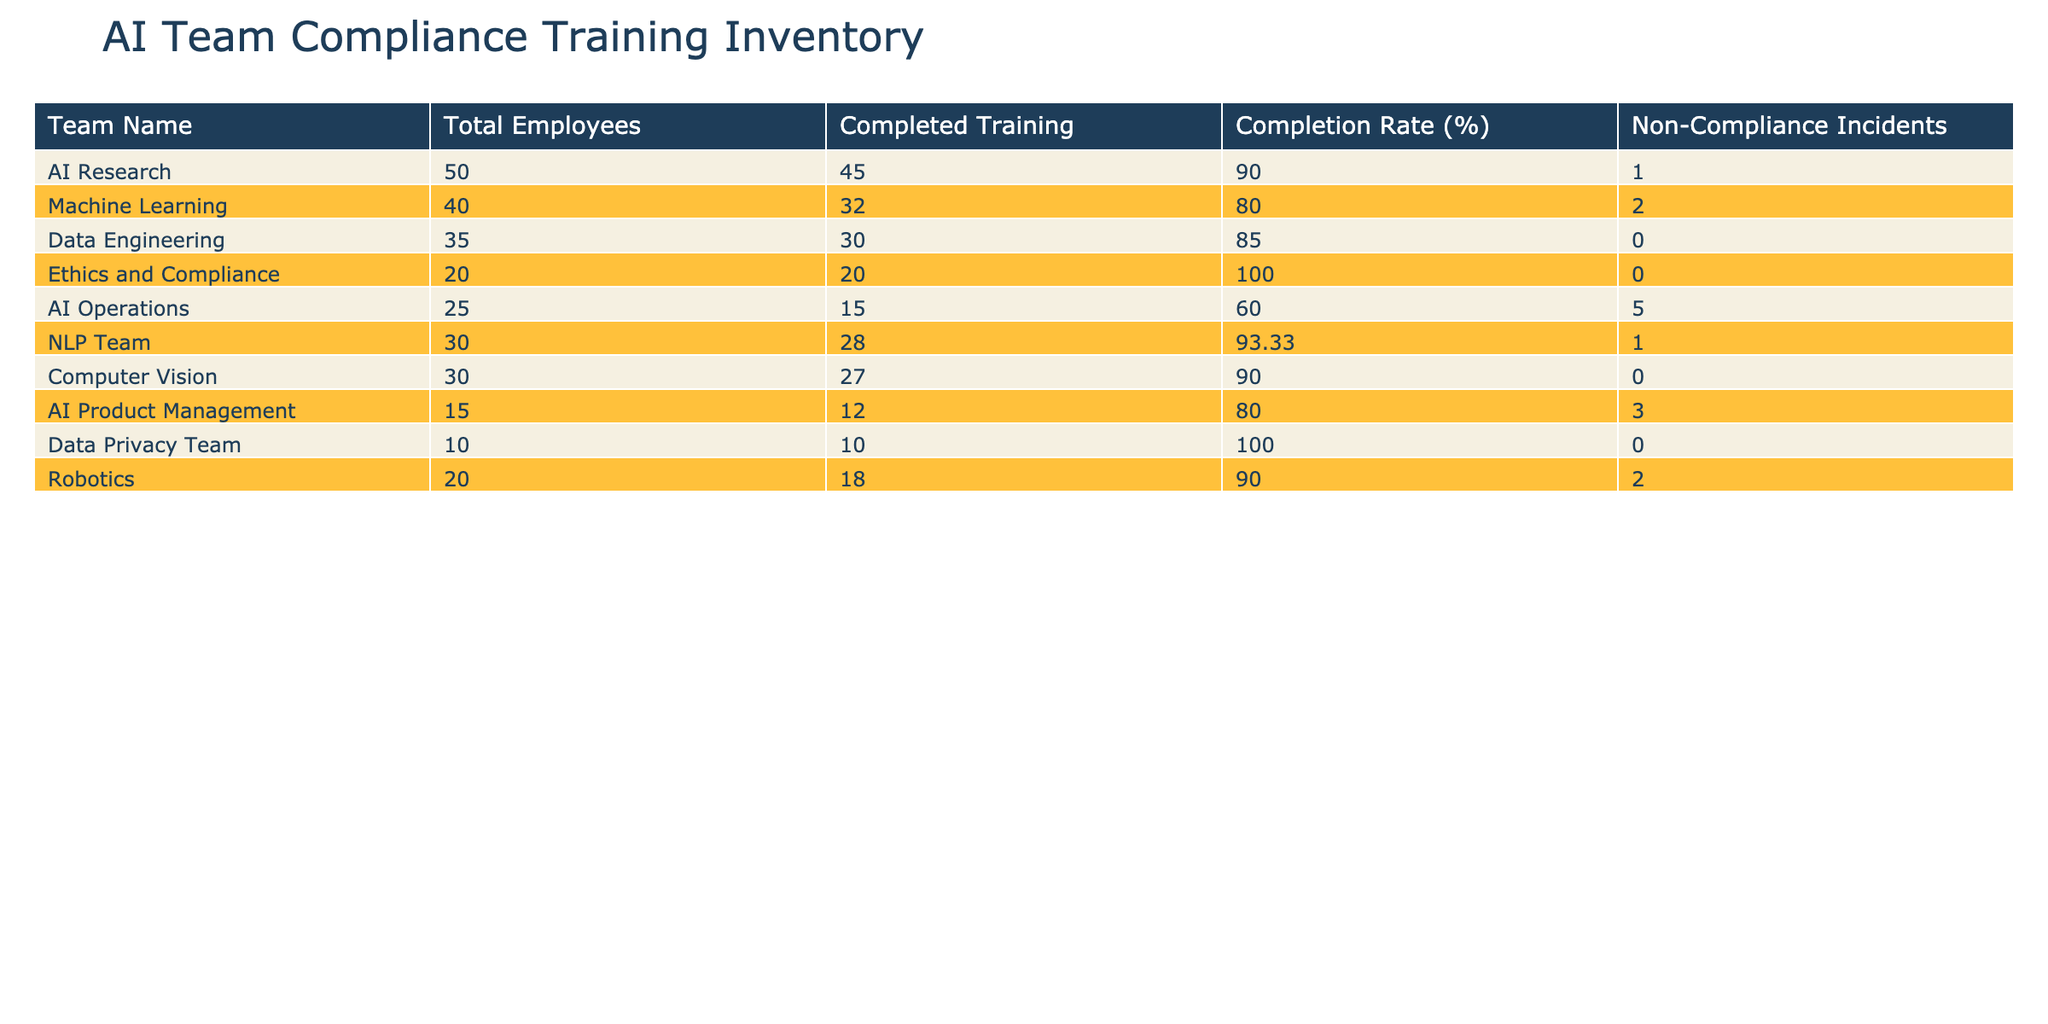What is the completion rate for the Ethics and Compliance team? The completion rate for the Ethics and Compliance team is directly listed in the table under the "Completion Rate (%)" column. The value for this team is 100%.
Answer: 100% Which team has the lowest completion rate? To find the team with the lowest completion rate, we need to look through the "Completion Rate (%)" column and identify the minimum value, which is 60% for the AI Operations team.
Answer: AI Operations How many non-compliance incidents were reported by the Data Engineering team? The number of non-compliance incidents for the Data Engineering team can be found in the "Non-Compliance Incidents" column. For this team, the number is 0.
Answer: 0 What is the average completion rate for all teams combined? To calculate the average, we first add all the completion rates: 90 + 80 + 85 + 100 + 60 + 93.33 + 90 + 80 + 100 + 90 = 968.33. Next, we divide by the number of teams, which is 10, resulting in an average of 96.83%.
Answer: 96.83% Is there any team that has a 100% training completion rate? We can review the completion rates listed in the table. The Data Privacy Team and the Ethics and Compliance Team both have a completion rate of 100%. Thus, the answer is yes, there are teams with 100%.
Answer: Yes How many total employees belong to all listed teams? To compute the total number of employees, sum the values in the "Total Employees" column: 50 + 40 + 35 + 20 + 25 + 30 + 30 + 15 + 10 + 20 =  355.
Answer: 355 What is the difference in completion rates between the Machine Learning team and the NLP Team? First, identify the completion rates; the Machine Learning team has an 80% completion rate and the NLP Team has 93.33%. The difference is calculated as 93.33 - 80 = 13.33%.
Answer: 13.33% Which two teams have reported the highest number of non-compliance incidents? The table shows the non-compliance incidents for each team. The AI Operations team reports 5 incidents, and the Machine Learning team reports 2 incidents. Thus, the two teams with the highest incidents are AI Operations and Machine Learning.
Answer: AI Operations and Machine Learning Are there any teams that reported zero non-compliance incidents? By checking the "Non-Compliance Incidents" column, we see that the Data Engineering team and the Ethics and Compliance team both reported 0 incidents. Consequently, the answer is yes, there are teams with zero incidents.
Answer: Yes 